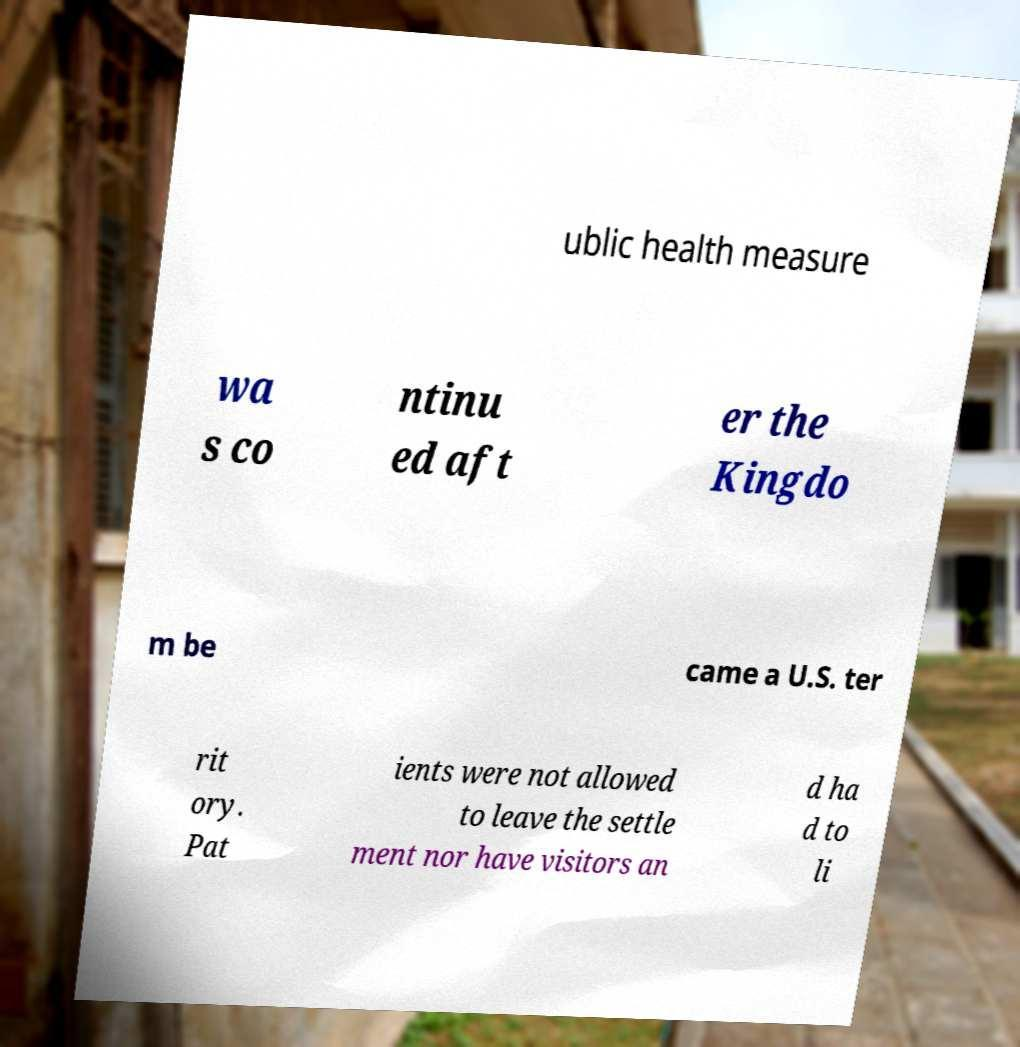Could you extract and type out the text from this image? ublic health measure wa s co ntinu ed aft er the Kingdo m be came a U.S. ter rit ory. Pat ients were not allowed to leave the settle ment nor have visitors an d ha d to li 